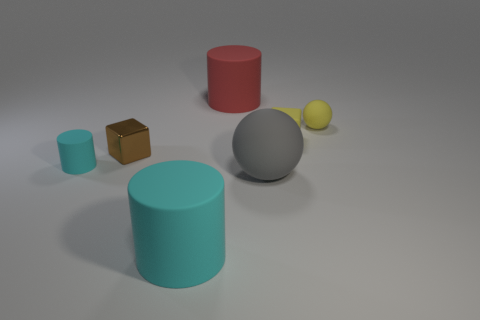Subtract all big cyan cylinders. How many cylinders are left? 2 Subtract all red cylinders. How many cylinders are left? 2 Subtract 1 balls. How many balls are left? 1 Subtract all cylinders. How many objects are left? 4 Add 2 red cylinders. How many objects exist? 9 Add 7 tiny brown shiny cubes. How many tiny brown shiny cubes are left? 8 Add 4 big matte cylinders. How many big matte cylinders exist? 6 Subtract 0 brown balls. How many objects are left? 7 Subtract all green balls. Subtract all yellow blocks. How many balls are left? 2 Subtract all red balls. How many cyan cylinders are left? 2 